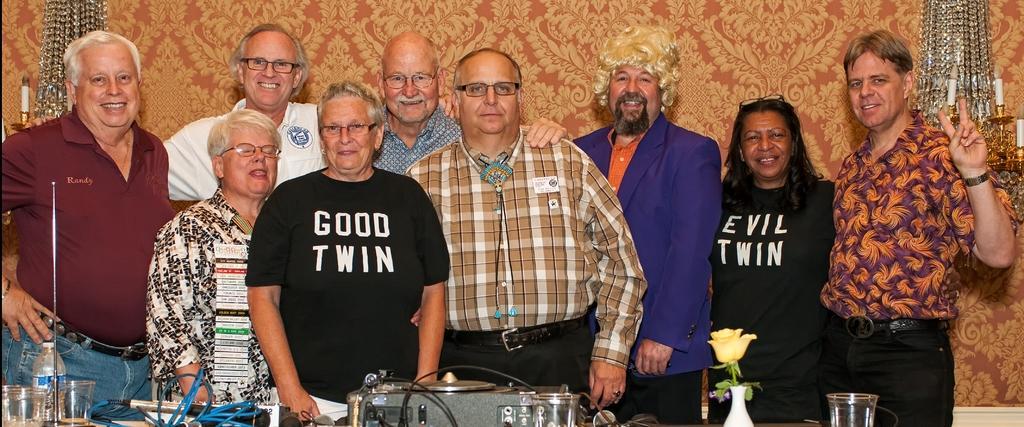Please provide a concise description of this image. In this picture there are people those who are standing in the center of the image and there is a table in front of them on which, there are glasses and other items. 